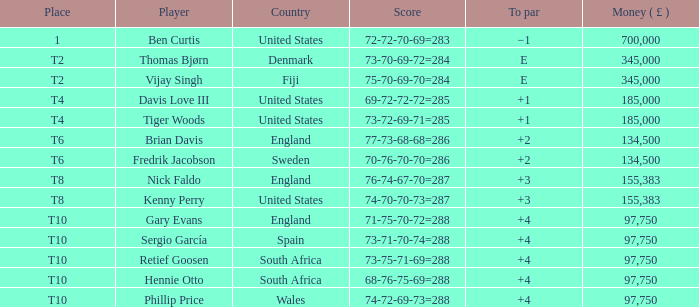What is the Place of Davis Love III with a To Par of +1? T4. 